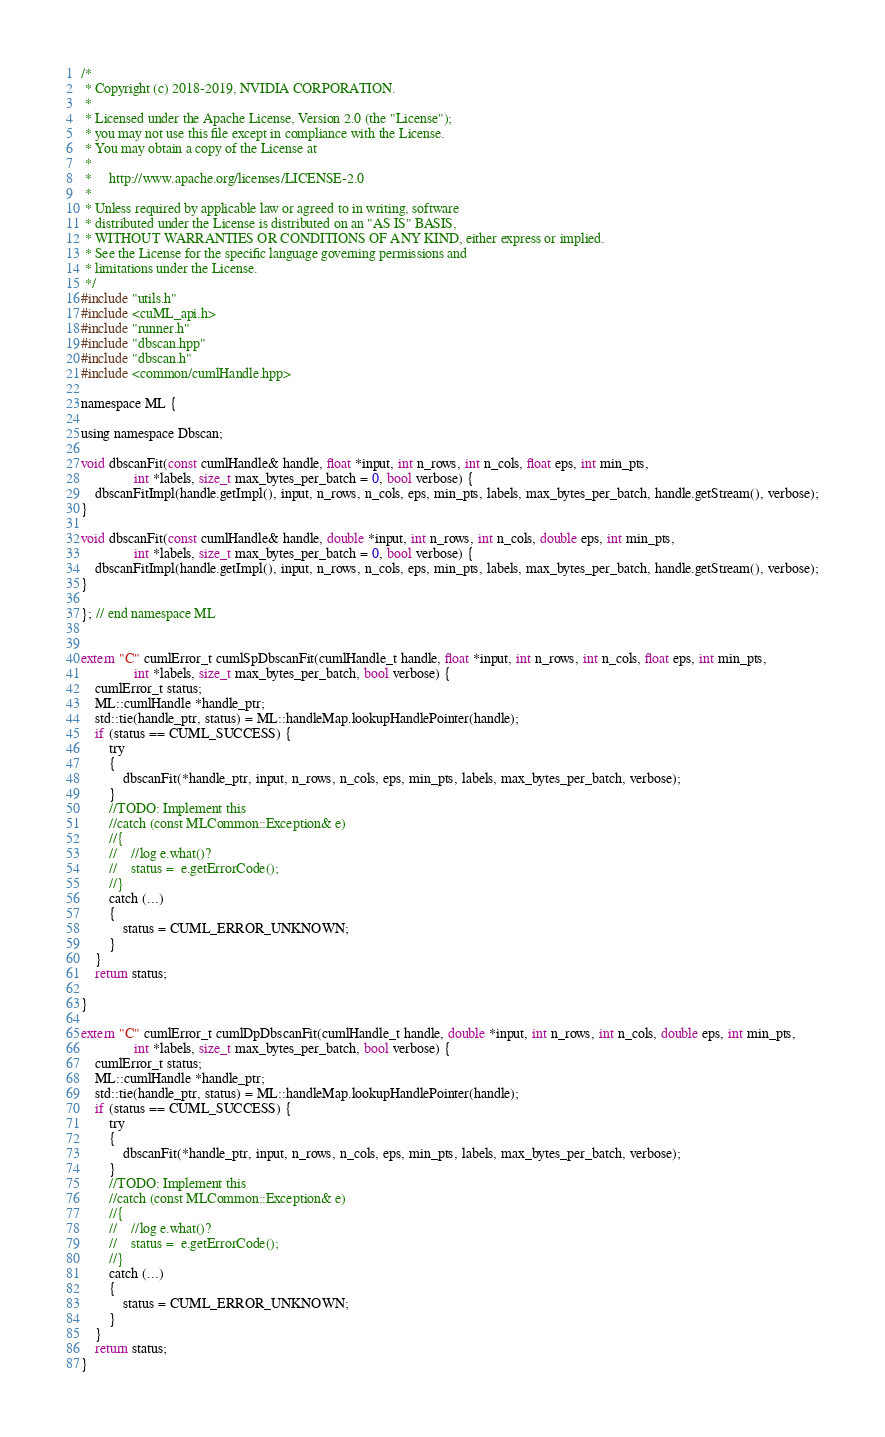<code> <loc_0><loc_0><loc_500><loc_500><_Cuda_>/*
 * Copyright (c) 2018-2019, NVIDIA CORPORATION.
 *
 * Licensed under the Apache License, Version 2.0 (the "License");
 * you may not use this file except in compliance with the License.
 * You may obtain a copy of the License at
 *
 *     http://www.apache.org/licenses/LICENSE-2.0
 *
 * Unless required by applicable law or agreed to in writing, software
 * distributed under the License is distributed on an "AS IS" BASIS,
 * WITHOUT WARRANTIES OR CONDITIONS OF ANY KIND, either express or implied.
 * See the License for the specific language governing permissions and
 * limitations under the License.
 */
#include "utils.h"
#include <cuML_api.h>
#include "runner.h"
#include "dbscan.hpp"
#include "dbscan.h"
#include <common/cumlHandle.hpp>

namespace ML {

using namespace Dbscan;

void dbscanFit(const cumlHandle& handle, float *input, int n_rows, int n_cols, float eps, int min_pts,
		       int *labels, size_t max_bytes_per_batch = 0, bool verbose) {
	dbscanFitImpl(handle.getImpl(), input, n_rows, n_cols, eps, min_pts, labels, max_bytes_per_batch, handle.getStream(), verbose);
}

void dbscanFit(const cumlHandle& handle, double *input, int n_rows, int n_cols, double eps, int min_pts,
		       int *labels, size_t max_bytes_per_batch = 0, bool verbose) {
	dbscanFitImpl(handle.getImpl(), input, n_rows, n_cols, eps, min_pts, labels, max_bytes_per_batch, handle.getStream(), verbose);
}

}; // end namespace ML


extern "C" cumlError_t cumlSpDbscanFit(cumlHandle_t handle, float *input, int n_rows, int n_cols, float eps, int min_pts,
               int *labels, size_t max_bytes_per_batch, bool verbose) {
    cumlError_t status;
    ML::cumlHandle *handle_ptr;
    std::tie(handle_ptr, status) = ML::handleMap.lookupHandlePointer(handle);
    if (status == CUML_SUCCESS) {
        try
        {
            dbscanFit(*handle_ptr, input, n_rows, n_cols, eps, min_pts, labels, max_bytes_per_batch, verbose);
        }
        //TODO: Implement this
        //catch (const MLCommon::Exception& e)
        //{
        //    //log e.what()?
        //    status =  e.getErrorCode();
        //}
        catch (...)
        {
            status = CUML_ERROR_UNKNOWN;
        }
    }
    return status;

}

extern "C" cumlError_t cumlDpDbscanFit(cumlHandle_t handle, double *input, int n_rows, int n_cols, double eps, int min_pts,
               int *labels, size_t max_bytes_per_batch, bool verbose) {
    cumlError_t status;
    ML::cumlHandle *handle_ptr;
    std::tie(handle_ptr, status) = ML::handleMap.lookupHandlePointer(handle);
    if (status == CUML_SUCCESS) {
        try
        {
            dbscanFit(*handle_ptr, input, n_rows, n_cols, eps, min_pts, labels, max_bytes_per_batch, verbose);
        }
        //TODO: Implement this
        //catch (const MLCommon::Exception& e)
        //{
        //    //log e.what()?
        //    status =  e.getErrorCode();
        //}
        catch (...)
        {
            status = CUML_ERROR_UNKNOWN;
        }
    }
    return status;
}
</code> 